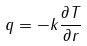Convert formula to latex. <formula><loc_0><loc_0><loc_500><loc_500>q = - k \frac { \partial T } { \partial r }</formula> 